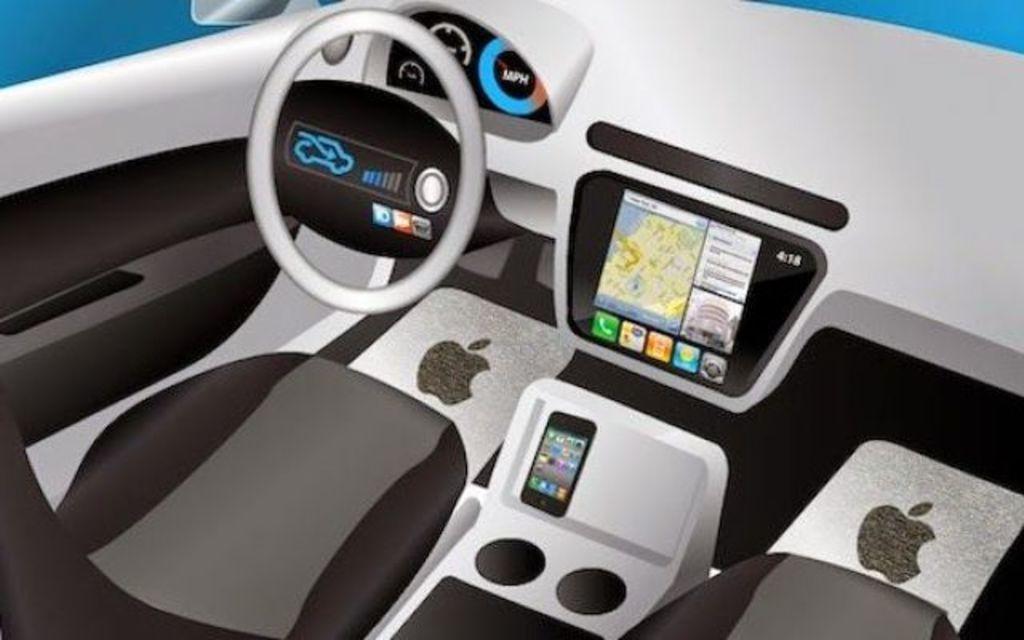How would you summarize this image in a sentence or two? In this picture I can see it looks like an inside part of a car, on the left side there is a steering. In the middle there is an electronic display, at the bottom there is a mobile phone. It looks like an animation. 